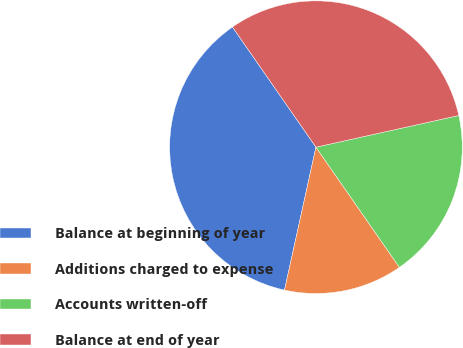<chart> <loc_0><loc_0><loc_500><loc_500><pie_chart><fcel>Balance at beginning of year<fcel>Additions charged to expense<fcel>Accounts written-off<fcel>Balance at end of year<nl><fcel>36.89%<fcel>13.11%<fcel>18.81%<fcel>31.19%<nl></chart> 